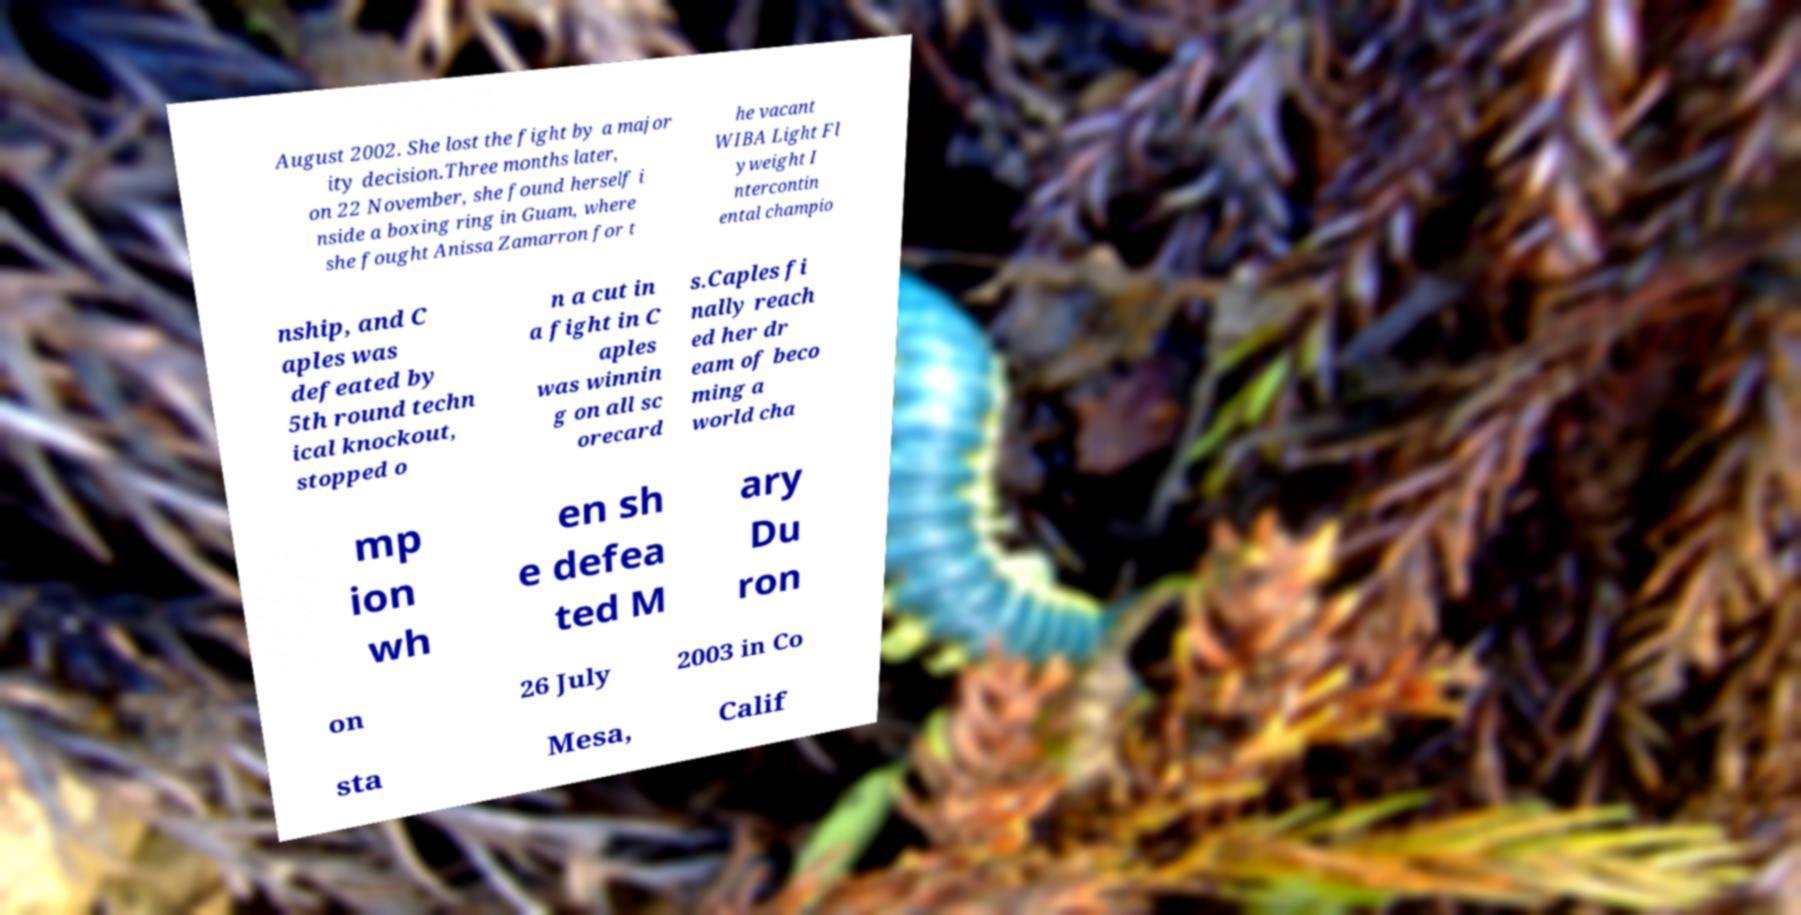Could you assist in decoding the text presented in this image and type it out clearly? August 2002. She lost the fight by a major ity decision.Three months later, on 22 November, she found herself i nside a boxing ring in Guam, where she fought Anissa Zamarron for t he vacant WIBA Light Fl yweight I ntercontin ental champio nship, and C aples was defeated by 5th round techn ical knockout, stopped o n a cut in a fight in C aples was winnin g on all sc orecard s.Caples fi nally reach ed her dr eam of beco ming a world cha mp ion wh en sh e defea ted M ary Du ron on 26 July 2003 in Co sta Mesa, Calif 